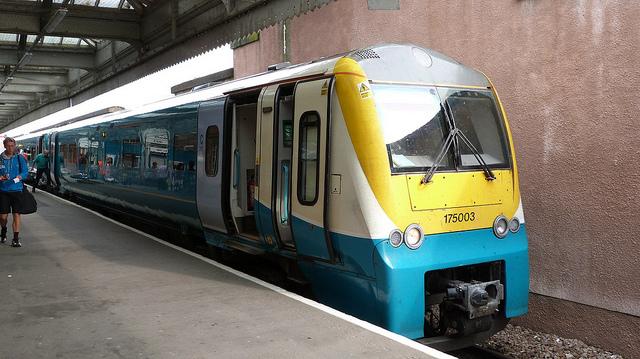Is there a reflection in the glass?
Concise answer only. Yes. Is this train's lights on?
Be succinct. Yes. Where is the open door?
Be succinct. On train. How many headlights are on the front of the train?
Concise answer only. 4. 